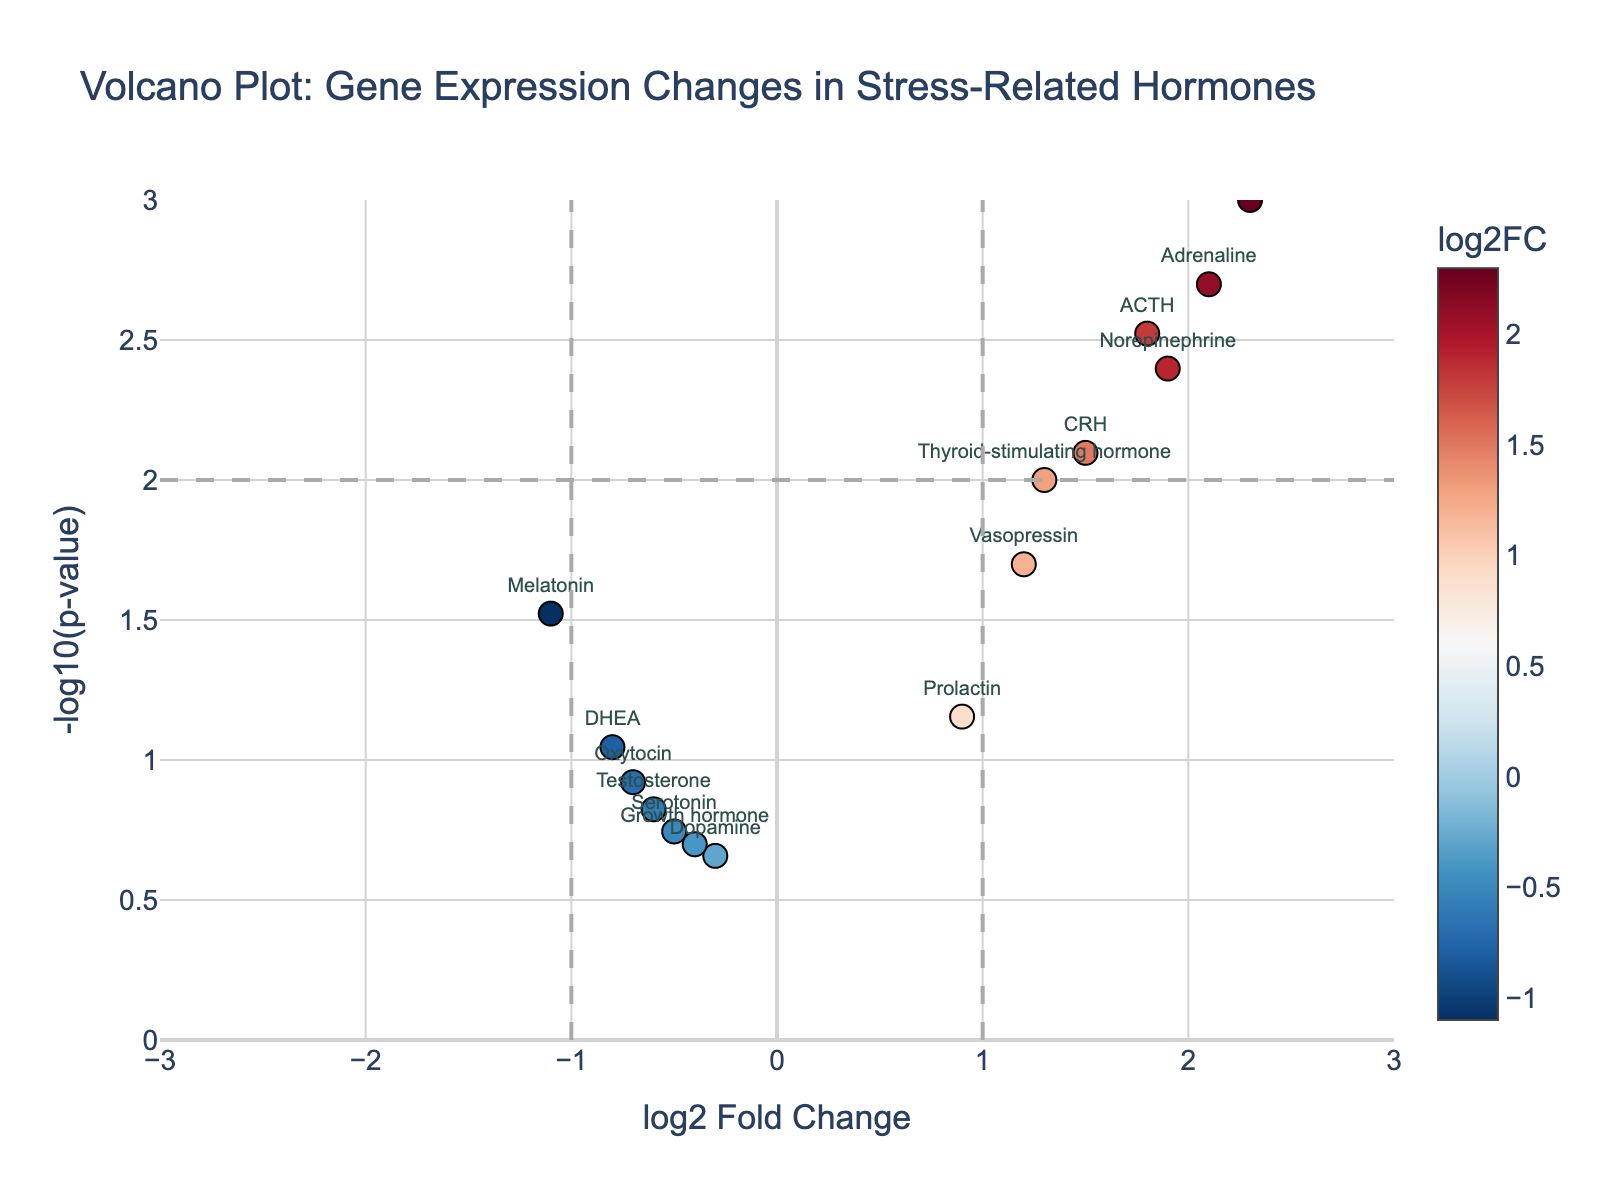What is the title of the plot? The title of the plot is mentioned at the top of the figure and summarizes what the plot is about.
Answer: Volcano Plot: Gene Expression Changes in Stress-Related Hormones How many data points are represented in the plot? Each data point represents a gene and its respective expression changes. By counting the data points, we see there are 15 points in total.
Answer: 15 Which gene has the highest log2FoldChange? The plot shows the log2FoldChange on the x-axis. The gene with the highest log2FoldChange is Cortisol, with a value of 2.3.
Answer: Cortisol Which gene has a log2FoldChange closest to zero? To find the gene with a log2FoldChange closest to zero, look for the data point nearest to the y-axis (log2FoldChange = 0). The gene closest to zero is Dopamine, with a log2FoldChange of -0.3.
Answer: Dopamine Which gene has the smallest p-value? The p-value is represented as -log10(p-value) on the y-axis. The highest y-value corresponds to the smallest p-value. Cortisol has the smallest p-value with -log10(p-value) of 3.
Answer: Cortisol How many genes have a log2FoldChange greater than 1? By inspecting the plot, count the number of data points that are to the right of the line at log2FoldChange = 1. There are 4 such genes: Cortisol, ACTH, Adrenaline, and Norepinephrine.
Answer: 4 Which gene shows the most significant decrease in expression (negative log2FoldChange)? For the most significant decrease, look for the data point farthest to the left on the x-axis. Melatonin shows the most significant decrease with a log2FoldChange of -1.1.
Answer: Melatonin How many genes are considered statistically significant (p-value < 0.05)? Statistically significant genes are above the threshold line at -log10(p-value) = 1.3 (since -log10(0.05) ≈ 1.3). There are 8 such genes: Cortisol, ACTH, Adrenaline, Norepinephrine, CRH, Vasopressin, Thyroid-Stimulating Hormone, and Melatonin.
Answer: 8 Which gene has the highest -log10(p-value)? The highest -log10(p-value) corresponds to the smallest p-value. Cortisol has the highest -log10(p-value) at 3.
Answer: Cortisol 